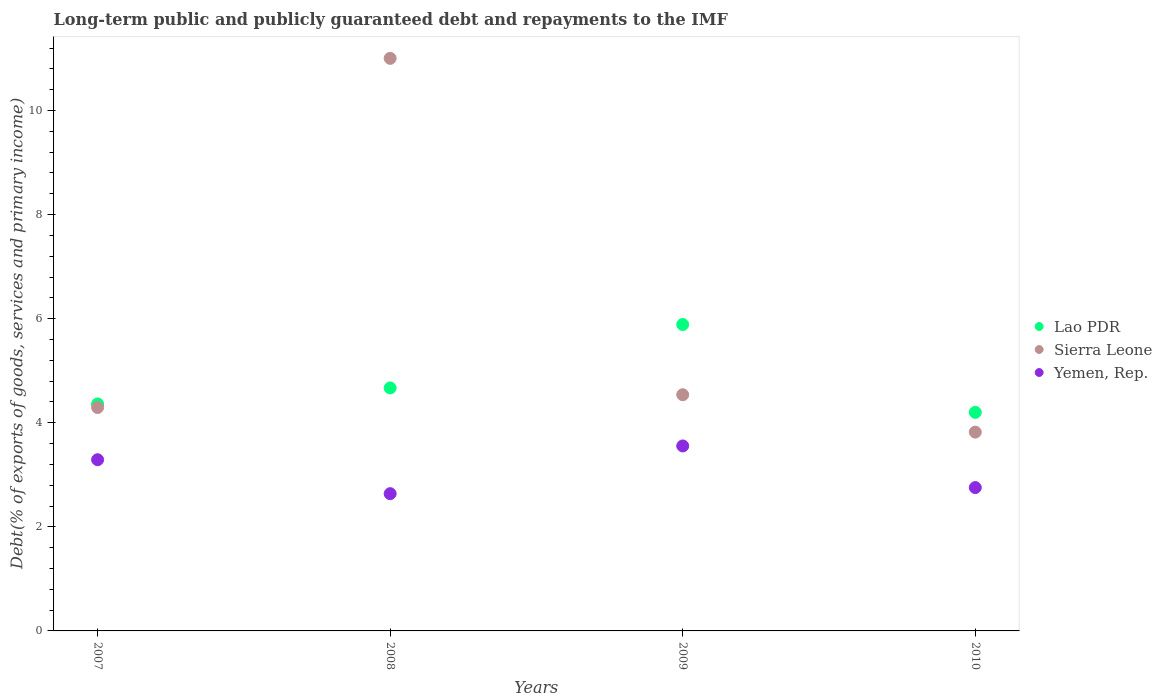What is the debt and repayments in Lao PDR in 2009?
Provide a succinct answer. 5.89. Across all years, what is the maximum debt and repayments in Yemen, Rep.?
Give a very brief answer. 3.55. Across all years, what is the minimum debt and repayments in Sierra Leone?
Ensure brevity in your answer.  3.82. In which year was the debt and repayments in Sierra Leone maximum?
Your answer should be compact. 2008. What is the total debt and repayments in Yemen, Rep. in the graph?
Offer a very short reply. 12.24. What is the difference between the debt and repayments in Sierra Leone in 2008 and that in 2010?
Offer a very short reply. 7.18. What is the difference between the debt and repayments in Yemen, Rep. in 2009 and the debt and repayments in Sierra Leone in 2010?
Keep it short and to the point. -0.27. What is the average debt and repayments in Yemen, Rep. per year?
Give a very brief answer. 3.06. In the year 2008, what is the difference between the debt and repayments in Sierra Leone and debt and repayments in Yemen, Rep.?
Offer a terse response. 8.37. What is the ratio of the debt and repayments in Yemen, Rep. in 2007 to that in 2008?
Your answer should be compact. 1.25. What is the difference between the highest and the second highest debt and repayments in Lao PDR?
Your response must be concise. 1.22. What is the difference between the highest and the lowest debt and repayments in Lao PDR?
Your response must be concise. 1.69. In how many years, is the debt and repayments in Lao PDR greater than the average debt and repayments in Lao PDR taken over all years?
Make the answer very short. 1. Is the sum of the debt and repayments in Sierra Leone in 2007 and 2009 greater than the maximum debt and repayments in Lao PDR across all years?
Your answer should be compact. Yes. Does the debt and repayments in Lao PDR monotonically increase over the years?
Keep it short and to the point. No. Is the debt and repayments in Yemen, Rep. strictly greater than the debt and repayments in Lao PDR over the years?
Ensure brevity in your answer.  No. How many dotlines are there?
Offer a very short reply. 3. What is the difference between two consecutive major ticks on the Y-axis?
Ensure brevity in your answer.  2. Are the values on the major ticks of Y-axis written in scientific E-notation?
Provide a succinct answer. No. How many legend labels are there?
Your answer should be compact. 3. How are the legend labels stacked?
Your answer should be very brief. Vertical. What is the title of the graph?
Provide a short and direct response. Long-term public and publicly guaranteed debt and repayments to the IMF. What is the label or title of the Y-axis?
Offer a very short reply. Debt(% of exports of goods, services and primary income). What is the Debt(% of exports of goods, services and primary income) of Lao PDR in 2007?
Your answer should be very brief. 4.36. What is the Debt(% of exports of goods, services and primary income) of Sierra Leone in 2007?
Your answer should be compact. 4.29. What is the Debt(% of exports of goods, services and primary income) in Yemen, Rep. in 2007?
Offer a very short reply. 3.29. What is the Debt(% of exports of goods, services and primary income) in Lao PDR in 2008?
Provide a short and direct response. 4.67. What is the Debt(% of exports of goods, services and primary income) of Sierra Leone in 2008?
Provide a succinct answer. 11. What is the Debt(% of exports of goods, services and primary income) in Yemen, Rep. in 2008?
Give a very brief answer. 2.64. What is the Debt(% of exports of goods, services and primary income) of Lao PDR in 2009?
Offer a very short reply. 5.89. What is the Debt(% of exports of goods, services and primary income) in Sierra Leone in 2009?
Ensure brevity in your answer.  4.54. What is the Debt(% of exports of goods, services and primary income) in Yemen, Rep. in 2009?
Your response must be concise. 3.55. What is the Debt(% of exports of goods, services and primary income) in Lao PDR in 2010?
Your answer should be compact. 4.2. What is the Debt(% of exports of goods, services and primary income) of Sierra Leone in 2010?
Offer a very short reply. 3.82. What is the Debt(% of exports of goods, services and primary income) in Yemen, Rep. in 2010?
Offer a terse response. 2.75. Across all years, what is the maximum Debt(% of exports of goods, services and primary income) in Lao PDR?
Provide a succinct answer. 5.89. Across all years, what is the maximum Debt(% of exports of goods, services and primary income) of Sierra Leone?
Give a very brief answer. 11. Across all years, what is the maximum Debt(% of exports of goods, services and primary income) in Yemen, Rep.?
Your answer should be very brief. 3.55. Across all years, what is the minimum Debt(% of exports of goods, services and primary income) in Lao PDR?
Provide a succinct answer. 4.2. Across all years, what is the minimum Debt(% of exports of goods, services and primary income) in Sierra Leone?
Offer a terse response. 3.82. Across all years, what is the minimum Debt(% of exports of goods, services and primary income) in Yemen, Rep.?
Provide a short and direct response. 2.64. What is the total Debt(% of exports of goods, services and primary income) in Lao PDR in the graph?
Provide a short and direct response. 19.12. What is the total Debt(% of exports of goods, services and primary income) of Sierra Leone in the graph?
Give a very brief answer. 23.65. What is the total Debt(% of exports of goods, services and primary income) of Yemen, Rep. in the graph?
Make the answer very short. 12.24. What is the difference between the Debt(% of exports of goods, services and primary income) in Lao PDR in 2007 and that in 2008?
Offer a terse response. -0.31. What is the difference between the Debt(% of exports of goods, services and primary income) in Sierra Leone in 2007 and that in 2008?
Offer a very short reply. -6.71. What is the difference between the Debt(% of exports of goods, services and primary income) of Yemen, Rep. in 2007 and that in 2008?
Keep it short and to the point. 0.65. What is the difference between the Debt(% of exports of goods, services and primary income) in Lao PDR in 2007 and that in 2009?
Your answer should be very brief. -1.53. What is the difference between the Debt(% of exports of goods, services and primary income) in Sierra Leone in 2007 and that in 2009?
Make the answer very short. -0.25. What is the difference between the Debt(% of exports of goods, services and primary income) of Yemen, Rep. in 2007 and that in 2009?
Offer a very short reply. -0.26. What is the difference between the Debt(% of exports of goods, services and primary income) of Lao PDR in 2007 and that in 2010?
Your response must be concise. 0.16. What is the difference between the Debt(% of exports of goods, services and primary income) of Sierra Leone in 2007 and that in 2010?
Offer a very short reply. 0.47. What is the difference between the Debt(% of exports of goods, services and primary income) of Yemen, Rep. in 2007 and that in 2010?
Ensure brevity in your answer.  0.54. What is the difference between the Debt(% of exports of goods, services and primary income) of Lao PDR in 2008 and that in 2009?
Your response must be concise. -1.22. What is the difference between the Debt(% of exports of goods, services and primary income) in Sierra Leone in 2008 and that in 2009?
Keep it short and to the point. 6.46. What is the difference between the Debt(% of exports of goods, services and primary income) of Yemen, Rep. in 2008 and that in 2009?
Offer a very short reply. -0.92. What is the difference between the Debt(% of exports of goods, services and primary income) of Lao PDR in 2008 and that in 2010?
Offer a very short reply. 0.47. What is the difference between the Debt(% of exports of goods, services and primary income) in Sierra Leone in 2008 and that in 2010?
Offer a very short reply. 7.18. What is the difference between the Debt(% of exports of goods, services and primary income) of Yemen, Rep. in 2008 and that in 2010?
Make the answer very short. -0.12. What is the difference between the Debt(% of exports of goods, services and primary income) of Lao PDR in 2009 and that in 2010?
Your response must be concise. 1.69. What is the difference between the Debt(% of exports of goods, services and primary income) of Sierra Leone in 2009 and that in 2010?
Provide a short and direct response. 0.72. What is the difference between the Debt(% of exports of goods, services and primary income) of Yemen, Rep. in 2009 and that in 2010?
Your answer should be compact. 0.8. What is the difference between the Debt(% of exports of goods, services and primary income) of Lao PDR in 2007 and the Debt(% of exports of goods, services and primary income) of Sierra Leone in 2008?
Ensure brevity in your answer.  -6.64. What is the difference between the Debt(% of exports of goods, services and primary income) of Lao PDR in 2007 and the Debt(% of exports of goods, services and primary income) of Yemen, Rep. in 2008?
Ensure brevity in your answer.  1.72. What is the difference between the Debt(% of exports of goods, services and primary income) of Sierra Leone in 2007 and the Debt(% of exports of goods, services and primary income) of Yemen, Rep. in 2008?
Make the answer very short. 1.66. What is the difference between the Debt(% of exports of goods, services and primary income) in Lao PDR in 2007 and the Debt(% of exports of goods, services and primary income) in Sierra Leone in 2009?
Offer a terse response. -0.18. What is the difference between the Debt(% of exports of goods, services and primary income) in Lao PDR in 2007 and the Debt(% of exports of goods, services and primary income) in Yemen, Rep. in 2009?
Keep it short and to the point. 0.81. What is the difference between the Debt(% of exports of goods, services and primary income) of Sierra Leone in 2007 and the Debt(% of exports of goods, services and primary income) of Yemen, Rep. in 2009?
Your answer should be very brief. 0.74. What is the difference between the Debt(% of exports of goods, services and primary income) in Lao PDR in 2007 and the Debt(% of exports of goods, services and primary income) in Sierra Leone in 2010?
Ensure brevity in your answer.  0.54. What is the difference between the Debt(% of exports of goods, services and primary income) of Lao PDR in 2007 and the Debt(% of exports of goods, services and primary income) of Yemen, Rep. in 2010?
Your answer should be very brief. 1.61. What is the difference between the Debt(% of exports of goods, services and primary income) in Sierra Leone in 2007 and the Debt(% of exports of goods, services and primary income) in Yemen, Rep. in 2010?
Your answer should be very brief. 1.54. What is the difference between the Debt(% of exports of goods, services and primary income) in Lao PDR in 2008 and the Debt(% of exports of goods, services and primary income) in Sierra Leone in 2009?
Offer a very short reply. 0.13. What is the difference between the Debt(% of exports of goods, services and primary income) in Lao PDR in 2008 and the Debt(% of exports of goods, services and primary income) in Yemen, Rep. in 2009?
Your answer should be very brief. 1.11. What is the difference between the Debt(% of exports of goods, services and primary income) of Sierra Leone in 2008 and the Debt(% of exports of goods, services and primary income) of Yemen, Rep. in 2009?
Make the answer very short. 7.45. What is the difference between the Debt(% of exports of goods, services and primary income) in Lao PDR in 2008 and the Debt(% of exports of goods, services and primary income) in Sierra Leone in 2010?
Provide a short and direct response. 0.85. What is the difference between the Debt(% of exports of goods, services and primary income) of Lao PDR in 2008 and the Debt(% of exports of goods, services and primary income) of Yemen, Rep. in 2010?
Offer a very short reply. 1.91. What is the difference between the Debt(% of exports of goods, services and primary income) in Sierra Leone in 2008 and the Debt(% of exports of goods, services and primary income) in Yemen, Rep. in 2010?
Offer a very short reply. 8.25. What is the difference between the Debt(% of exports of goods, services and primary income) in Lao PDR in 2009 and the Debt(% of exports of goods, services and primary income) in Sierra Leone in 2010?
Your answer should be very brief. 2.07. What is the difference between the Debt(% of exports of goods, services and primary income) in Lao PDR in 2009 and the Debt(% of exports of goods, services and primary income) in Yemen, Rep. in 2010?
Your response must be concise. 3.13. What is the difference between the Debt(% of exports of goods, services and primary income) in Sierra Leone in 2009 and the Debt(% of exports of goods, services and primary income) in Yemen, Rep. in 2010?
Make the answer very short. 1.78. What is the average Debt(% of exports of goods, services and primary income) of Lao PDR per year?
Ensure brevity in your answer.  4.78. What is the average Debt(% of exports of goods, services and primary income) in Sierra Leone per year?
Provide a short and direct response. 5.91. What is the average Debt(% of exports of goods, services and primary income) in Yemen, Rep. per year?
Provide a short and direct response. 3.06. In the year 2007, what is the difference between the Debt(% of exports of goods, services and primary income) in Lao PDR and Debt(% of exports of goods, services and primary income) in Sierra Leone?
Your response must be concise. 0.07. In the year 2007, what is the difference between the Debt(% of exports of goods, services and primary income) of Lao PDR and Debt(% of exports of goods, services and primary income) of Yemen, Rep.?
Provide a succinct answer. 1.07. In the year 2008, what is the difference between the Debt(% of exports of goods, services and primary income) of Lao PDR and Debt(% of exports of goods, services and primary income) of Sierra Leone?
Ensure brevity in your answer.  -6.33. In the year 2008, what is the difference between the Debt(% of exports of goods, services and primary income) in Lao PDR and Debt(% of exports of goods, services and primary income) in Yemen, Rep.?
Provide a short and direct response. 2.03. In the year 2008, what is the difference between the Debt(% of exports of goods, services and primary income) in Sierra Leone and Debt(% of exports of goods, services and primary income) in Yemen, Rep.?
Keep it short and to the point. 8.37. In the year 2009, what is the difference between the Debt(% of exports of goods, services and primary income) in Lao PDR and Debt(% of exports of goods, services and primary income) in Sierra Leone?
Provide a succinct answer. 1.35. In the year 2009, what is the difference between the Debt(% of exports of goods, services and primary income) of Lao PDR and Debt(% of exports of goods, services and primary income) of Yemen, Rep.?
Your response must be concise. 2.33. In the year 2009, what is the difference between the Debt(% of exports of goods, services and primary income) in Sierra Leone and Debt(% of exports of goods, services and primary income) in Yemen, Rep.?
Make the answer very short. 0.98. In the year 2010, what is the difference between the Debt(% of exports of goods, services and primary income) of Lao PDR and Debt(% of exports of goods, services and primary income) of Sierra Leone?
Give a very brief answer. 0.38. In the year 2010, what is the difference between the Debt(% of exports of goods, services and primary income) in Lao PDR and Debt(% of exports of goods, services and primary income) in Yemen, Rep.?
Offer a terse response. 1.45. In the year 2010, what is the difference between the Debt(% of exports of goods, services and primary income) in Sierra Leone and Debt(% of exports of goods, services and primary income) in Yemen, Rep.?
Offer a very short reply. 1.07. What is the ratio of the Debt(% of exports of goods, services and primary income) of Lao PDR in 2007 to that in 2008?
Provide a short and direct response. 0.93. What is the ratio of the Debt(% of exports of goods, services and primary income) of Sierra Leone in 2007 to that in 2008?
Offer a very short reply. 0.39. What is the ratio of the Debt(% of exports of goods, services and primary income) of Yemen, Rep. in 2007 to that in 2008?
Your answer should be very brief. 1.25. What is the ratio of the Debt(% of exports of goods, services and primary income) of Lao PDR in 2007 to that in 2009?
Your response must be concise. 0.74. What is the ratio of the Debt(% of exports of goods, services and primary income) of Sierra Leone in 2007 to that in 2009?
Provide a short and direct response. 0.95. What is the ratio of the Debt(% of exports of goods, services and primary income) of Yemen, Rep. in 2007 to that in 2009?
Offer a very short reply. 0.93. What is the ratio of the Debt(% of exports of goods, services and primary income) in Lao PDR in 2007 to that in 2010?
Ensure brevity in your answer.  1.04. What is the ratio of the Debt(% of exports of goods, services and primary income) in Sierra Leone in 2007 to that in 2010?
Keep it short and to the point. 1.12. What is the ratio of the Debt(% of exports of goods, services and primary income) in Yemen, Rep. in 2007 to that in 2010?
Keep it short and to the point. 1.19. What is the ratio of the Debt(% of exports of goods, services and primary income) of Lao PDR in 2008 to that in 2009?
Your response must be concise. 0.79. What is the ratio of the Debt(% of exports of goods, services and primary income) of Sierra Leone in 2008 to that in 2009?
Offer a very short reply. 2.42. What is the ratio of the Debt(% of exports of goods, services and primary income) of Yemen, Rep. in 2008 to that in 2009?
Make the answer very short. 0.74. What is the ratio of the Debt(% of exports of goods, services and primary income) of Lao PDR in 2008 to that in 2010?
Keep it short and to the point. 1.11. What is the ratio of the Debt(% of exports of goods, services and primary income) in Sierra Leone in 2008 to that in 2010?
Keep it short and to the point. 2.88. What is the ratio of the Debt(% of exports of goods, services and primary income) of Yemen, Rep. in 2008 to that in 2010?
Provide a succinct answer. 0.96. What is the ratio of the Debt(% of exports of goods, services and primary income) of Lao PDR in 2009 to that in 2010?
Your answer should be compact. 1.4. What is the ratio of the Debt(% of exports of goods, services and primary income) in Sierra Leone in 2009 to that in 2010?
Give a very brief answer. 1.19. What is the ratio of the Debt(% of exports of goods, services and primary income) of Yemen, Rep. in 2009 to that in 2010?
Provide a succinct answer. 1.29. What is the difference between the highest and the second highest Debt(% of exports of goods, services and primary income) of Lao PDR?
Provide a succinct answer. 1.22. What is the difference between the highest and the second highest Debt(% of exports of goods, services and primary income) in Sierra Leone?
Ensure brevity in your answer.  6.46. What is the difference between the highest and the second highest Debt(% of exports of goods, services and primary income) in Yemen, Rep.?
Provide a succinct answer. 0.26. What is the difference between the highest and the lowest Debt(% of exports of goods, services and primary income) in Lao PDR?
Your response must be concise. 1.69. What is the difference between the highest and the lowest Debt(% of exports of goods, services and primary income) of Sierra Leone?
Provide a short and direct response. 7.18. What is the difference between the highest and the lowest Debt(% of exports of goods, services and primary income) of Yemen, Rep.?
Your answer should be very brief. 0.92. 